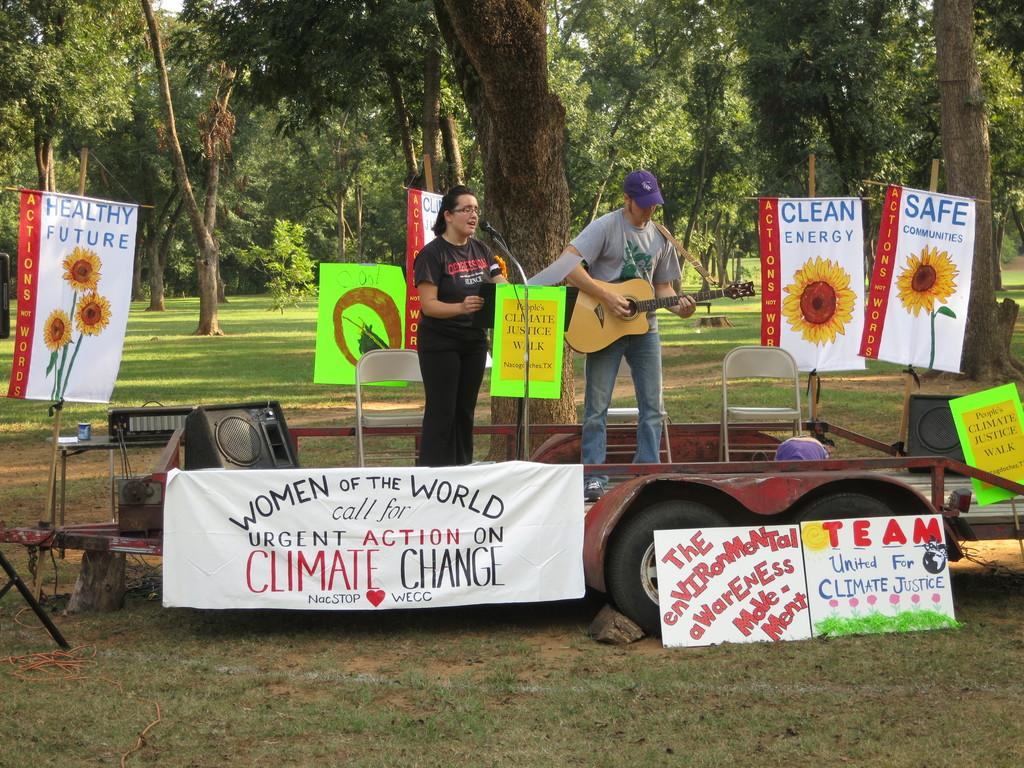How many people are present in the image? There are two people in the image. What is the man holding in the image? The man is holding a guitar. What object is used for amplifying sound in the image? There is a speaker in the background of the image. What can be seen in the background of the image? There are trees and chairs in the background of the image. What type of objects are hanging on the walls in the image? There are posters in the image. What type of wing is visible on the guitar in the image? There is no wing visible on the guitar in the image. What decision is the man making while holding the guitar in the image? There is no indication of a decision being made in the image; the man is simply holding a guitar. 